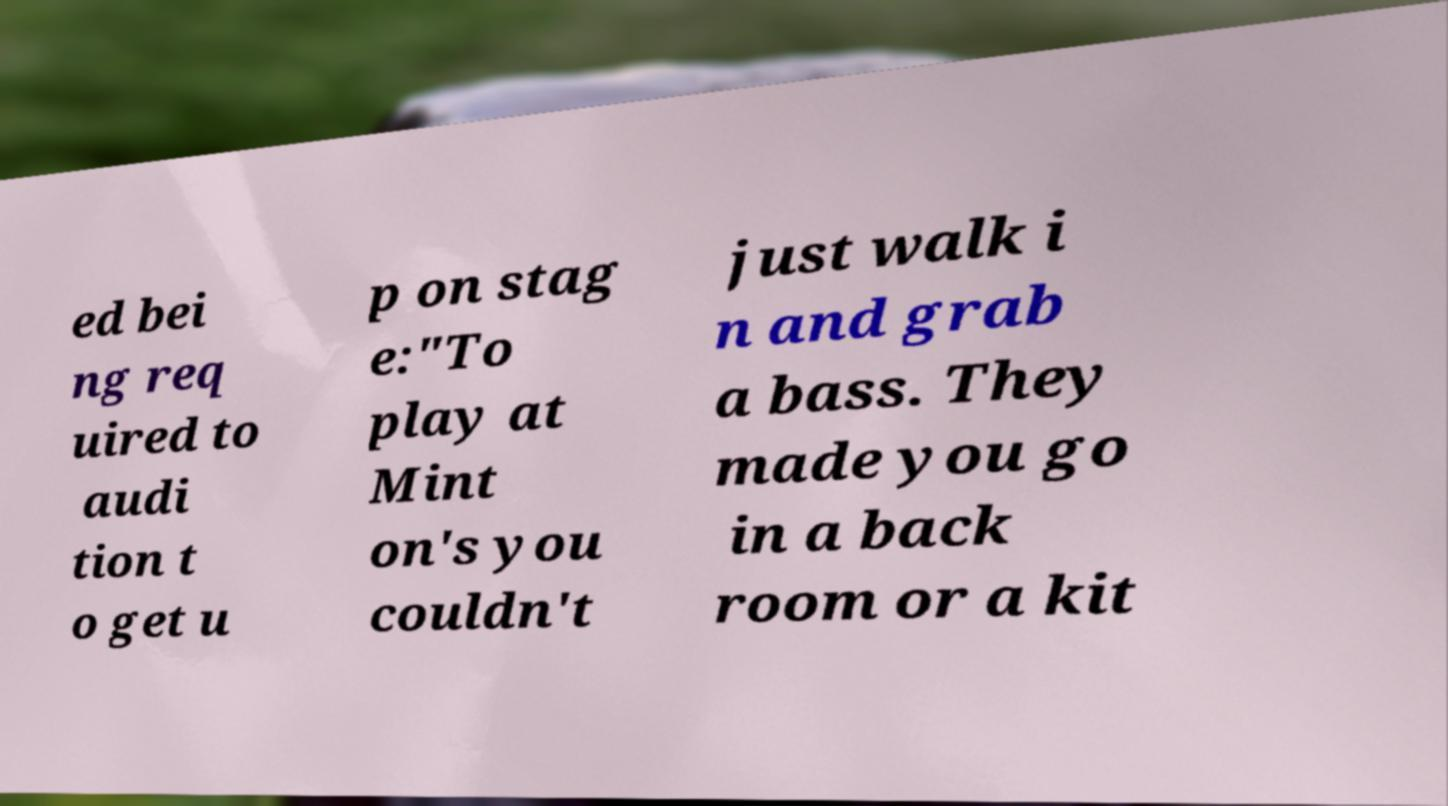Can you read and provide the text displayed in the image?This photo seems to have some interesting text. Can you extract and type it out for me? ed bei ng req uired to audi tion t o get u p on stag e:"To play at Mint on's you couldn't just walk i n and grab a bass. They made you go in a back room or a kit 